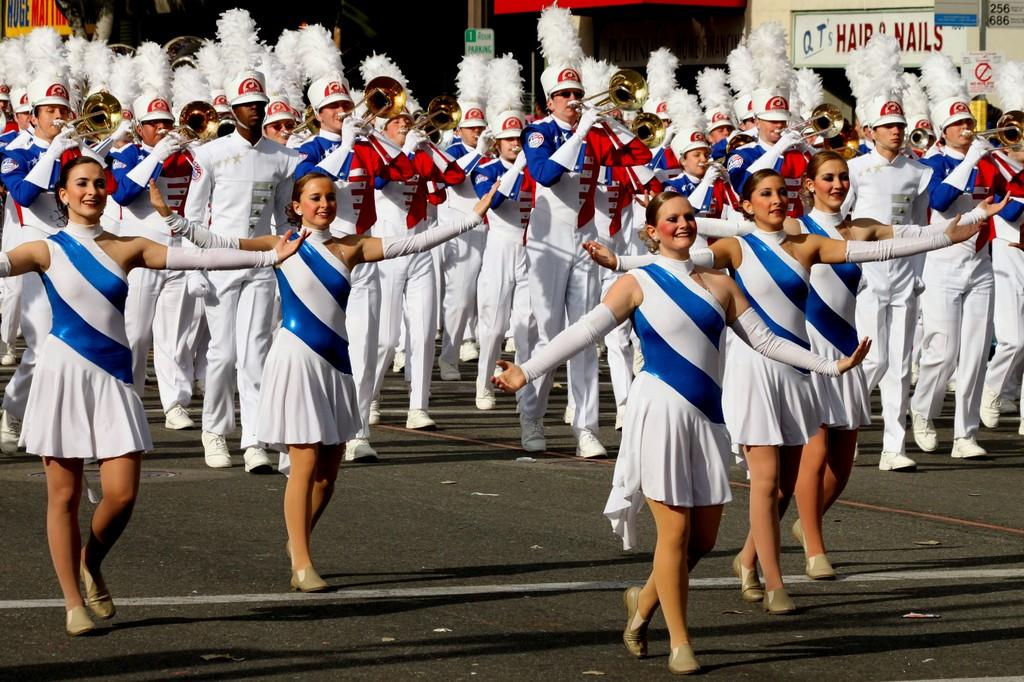<image>
Describe the image concisely. A marching band performs on the street in front of QT's Hair & Nails. 